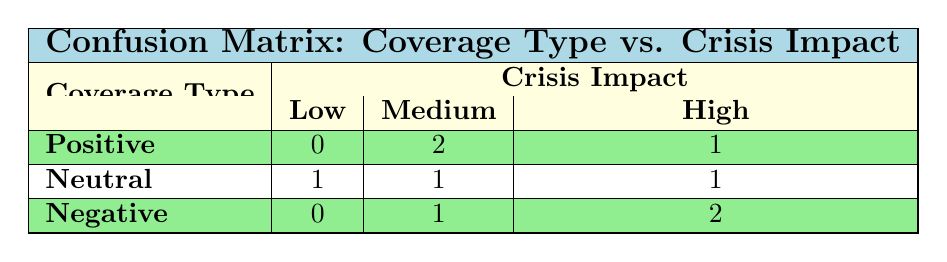What is the total count of positive coverage types in the matrix? The table shows 1 positive coverage type with low impact, 2 positive coverage types with medium impact, and 1 positive coverage type with high impact. Adding these up: 0 + 2 + 1 = 3.
Answer: 3 How many negative coverage types are associated with high impact? The table indicates that there are 2 negative coverage types that fall under high impact.
Answer: 2 What is the impact category with the least reported coverage type? Looking at the table, the counts show that the low impact category has 1 positive coverage type, 1 neutral coverage type, and 0 negative coverage types. Since the negative coverage type shows a count of 0, this is the least reported coverage type.
Answer: Negative Is there any coverage type that has a medium impact and is positive? The table indicates that there are 2 positive coverage types with medium impact, confirming the presence of positive coverage in this category.
Answer: Yes What is the difference in the number of neutral coverage types between low and medium impact? From the table, there is 1 neutral coverage type with low impact and 1 neutral coverage type with medium impact. Therefore, the difference is 1 - 1 = 0.
Answer: 0 What total number of coverage types is attributed to high impact crises? The table shows 1 positive, 1 neutral, and 2 negative coverage types associated with high impact crises. Adding these numbers together gives 1 + 1 + 2 = 4.
Answer: 4 Are there any coverage types that have no associated low impact crises? The positive and negative coverage types both have values of 0 for low impact in the table. Thus, both are associated with no low impact crises.
Answer: Yes What is the average impact distribution for negative coverage types? Negative coverage types show 0 low impact, 1 medium impact, and 2 high impacts. To find the average, we consider the values as (0 * 1 + 1 * 1 + 2 * 1) / 3 = (0 + 1 + 2) / 3 = 1. Therefore, the average is 1.
Answer: 1 